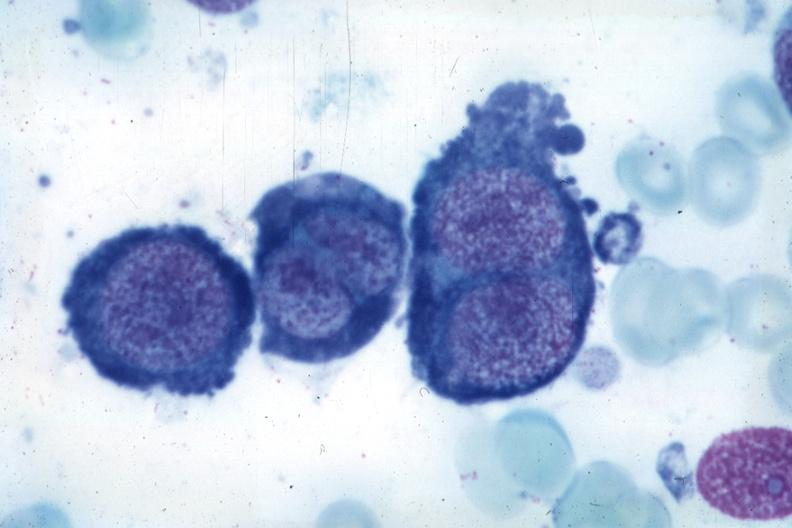s atherosclerosis present?
Answer the question using a single word or phrase. No 